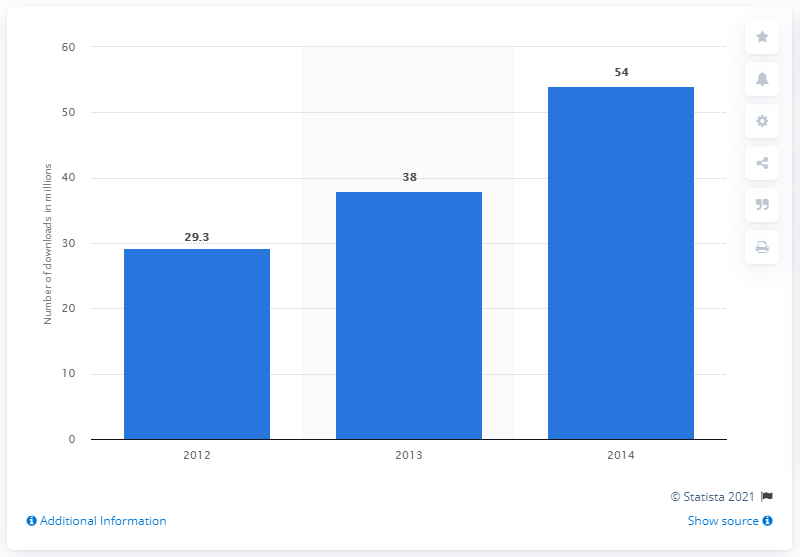Point out several critical features in this image. In 2014, a total of 54 podcasts were downloaded. In 2012, the average monthly download of NPR podcasts was 29.3. 